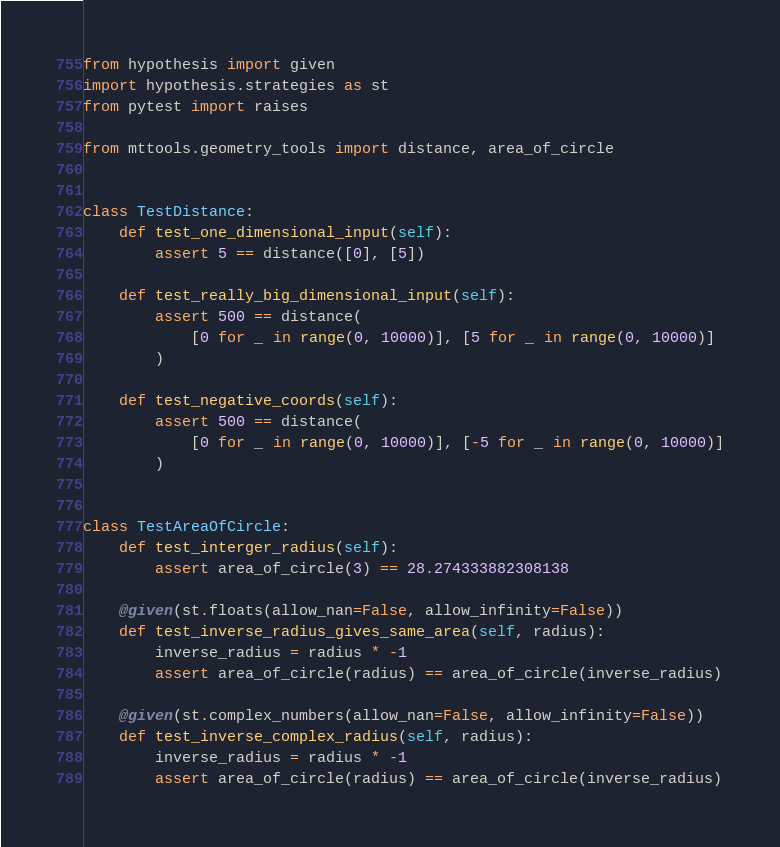<code> <loc_0><loc_0><loc_500><loc_500><_Python_>from hypothesis import given
import hypothesis.strategies as st
from pytest import raises

from mttools.geometry_tools import distance, area_of_circle


class TestDistance:
    def test_one_dimensional_input(self):
        assert 5 == distance([0], [5])

    def test_really_big_dimensional_input(self):
        assert 500 == distance(
            [0 for _ in range(0, 10000)], [5 for _ in range(0, 10000)]
        )

    def test_negative_coords(self):
        assert 500 == distance(
            [0 for _ in range(0, 10000)], [-5 for _ in range(0, 10000)]
        )


class TestAreaOfCircle:
    def test_interger_radius(self):
        assert area_of_circle(3) == 28.274333882308138

    @given(st.floats(allow_nan=False, allow_infinity=False))
    def test_inverse_radius_gives_same_area(self, radius):
        inverse_radius = radius * -1
        assert area_of_circle(radius) == area_of_circle(inverse_radius)

    @given(st.complex_numbers(allow_nan=False, allow_infinity=False))
    def test_inverse_complex_radius(self, radius):
        inverse_radius = radius * -1
        assert area_of_circle(radius) == area_of_circle(inverse_radius)
</code> 